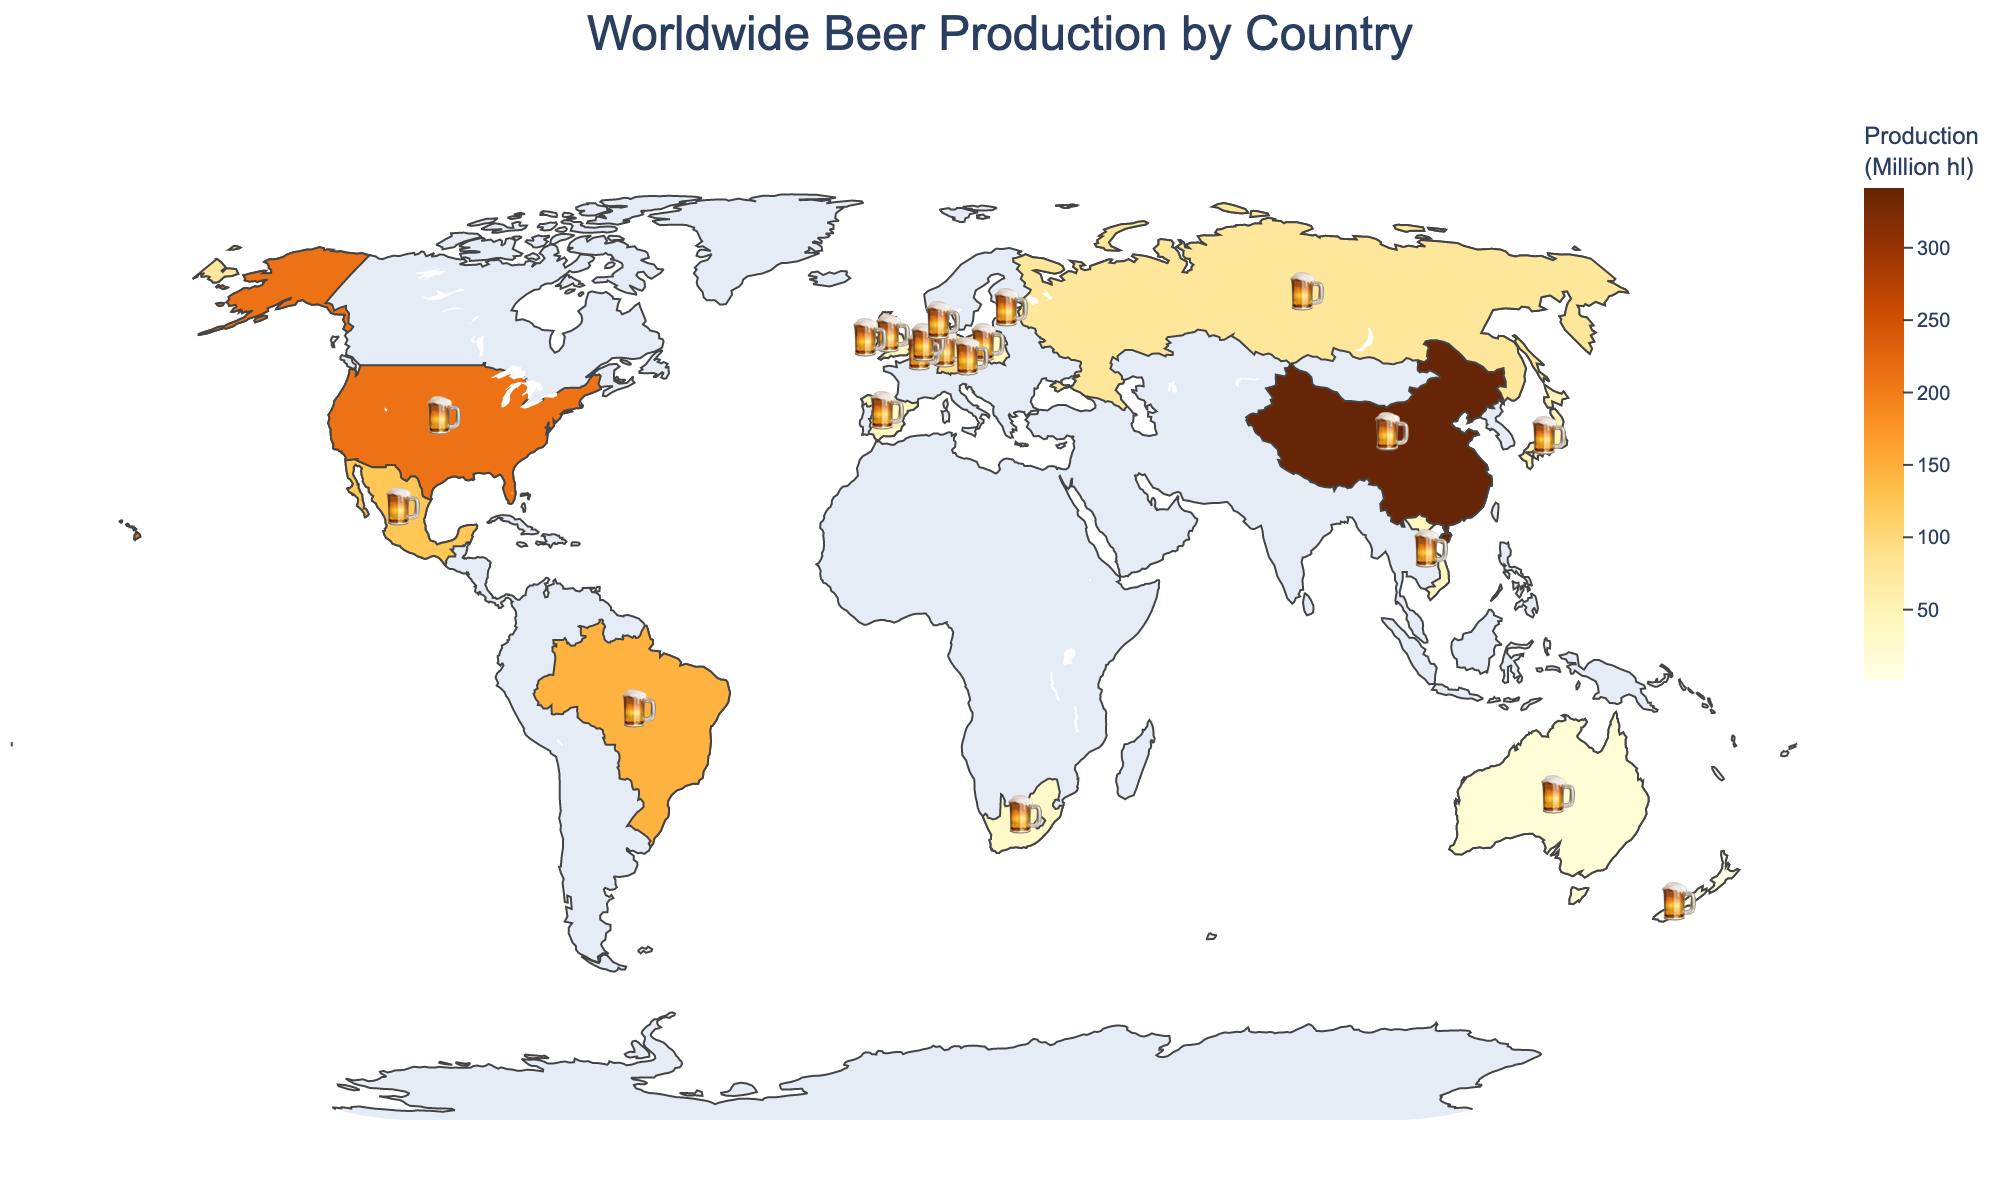What is the title of the figure? The title is usually found at the top of the figure.
Answer: Worldwide Beer Production by Country Which country has the highest beer production? The country with the darkest color represents the highest production.
Answer: China How many countries are shown on the map? Count all the distinct countries represented on the map.
Answer: 20 What is the beer production volume of Brazil? Look at the specified color for Brazil and the associated legend or hover information.
Answer: 145.8 million hectoliters Which countries are the top three beer producers? Identify the three countries with the darkest colors (highest values).
Answer: China, United States, Brazil How much more beer does the United States produce compared to Germany? Subtract Germany's production volume from the United States' volume. (211.7 - 91.6) = 120.1
Answer: 120.1 million hectoliters What is the combined beer production of Mexico and Germany? Add Mexico's and Germany's production volumes together. (124.5 + 91.6) = 216.1
Answer: 216.1 million hectoliters Which country in Europe has the highest beer production? Identify the European country with the highest value from the relevant colors.
Answer: Germany Which two countries have almost similar beer production volumes? Compare the values and find the closest pair.
Answer: United Kingdom and Poland (41.2 and 40.7 million hectoliters) What is the rank of Belgium in terms of beer production volume? Compare Belgium's production volume with others to determine its rank.
Answer: 11 